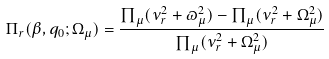<formula> <loc_0><loc_0><loc_500><loc_500>\Pi _ { r } ( \beta , q _ { 0 } ; \Omega _ { \mu } ) = \frac { \prod _ { \mu } ( \nu _ { r } ^ { 2 } + \varpi _ { \mu } ^ { 2 } ) - \prod _ { \mu } ( \nu _ { r } ^ { 2 } + \Omega _ { \mu } ^ { 2 } ) } { \prod _ { \mu } ( \nu _ { r } ^ { 2 } + \Omega _ { \mu } ^ { 2 } ) }</formula> 